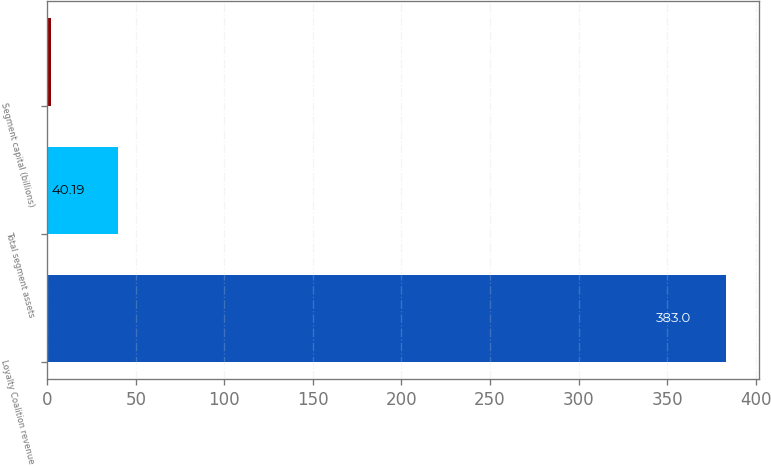Convert chart. <chart><loc_0><loc_0><loc_500><loc_500><bar_chart><fcel>Loyalty Coalition revenue<fcel>Total segment assets<fcel>Segment capital (billions)<nl><fcel>383<fcel>40.19<fcel>2.1<nl></chart> 